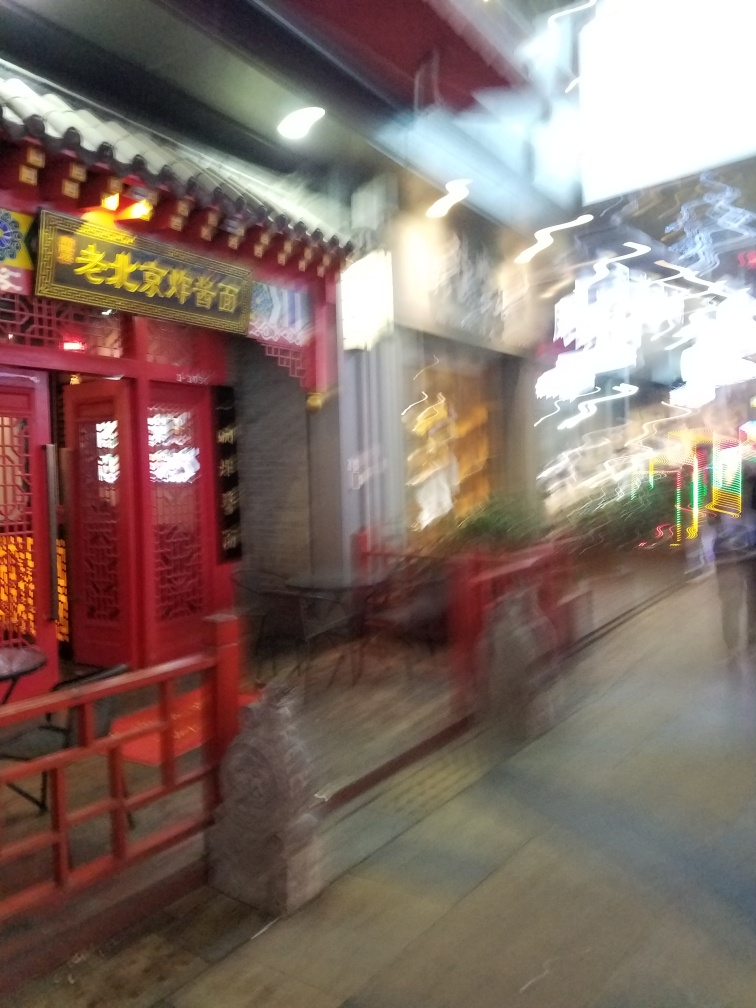What kind of businesses or activities typically take place in establishments like the one in this photo? Establishments like the one shown in the photo, with its classic Chinese architectural elements and welcoming entryway, often serve as tea houses, local eateries, or specialty shops. These places emphasize a cultural experience, and visitors can engage in traditional activities, sample regional cuisine, or purchase local crafts. 